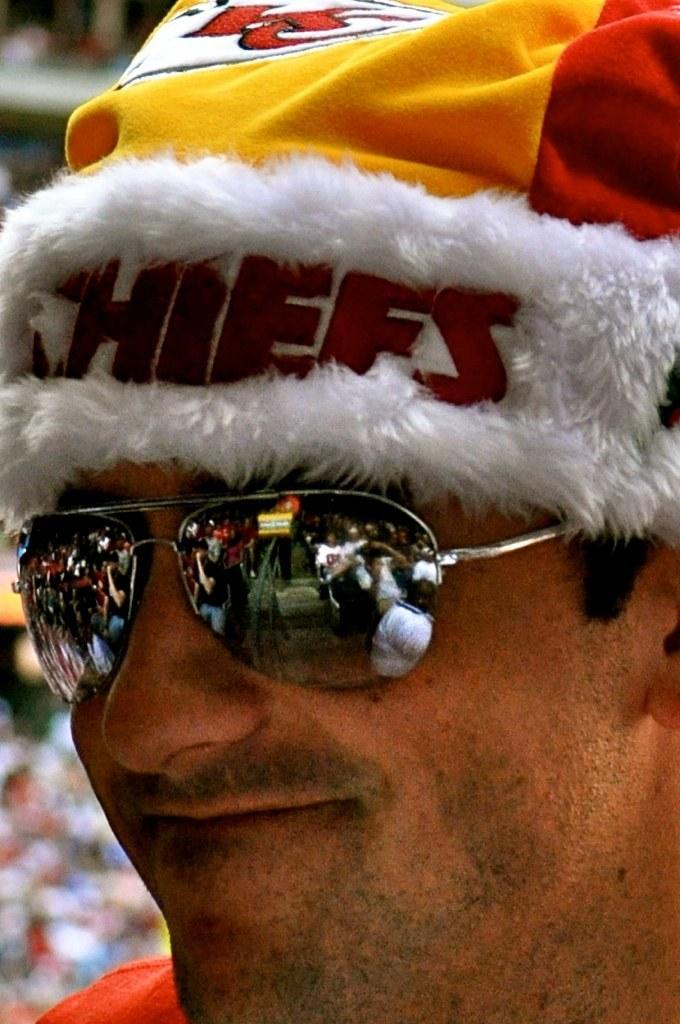Can you describe this image briefly? This image consists of a person. He is the man. Only the face is visible. He is wearing cap and goggles. 